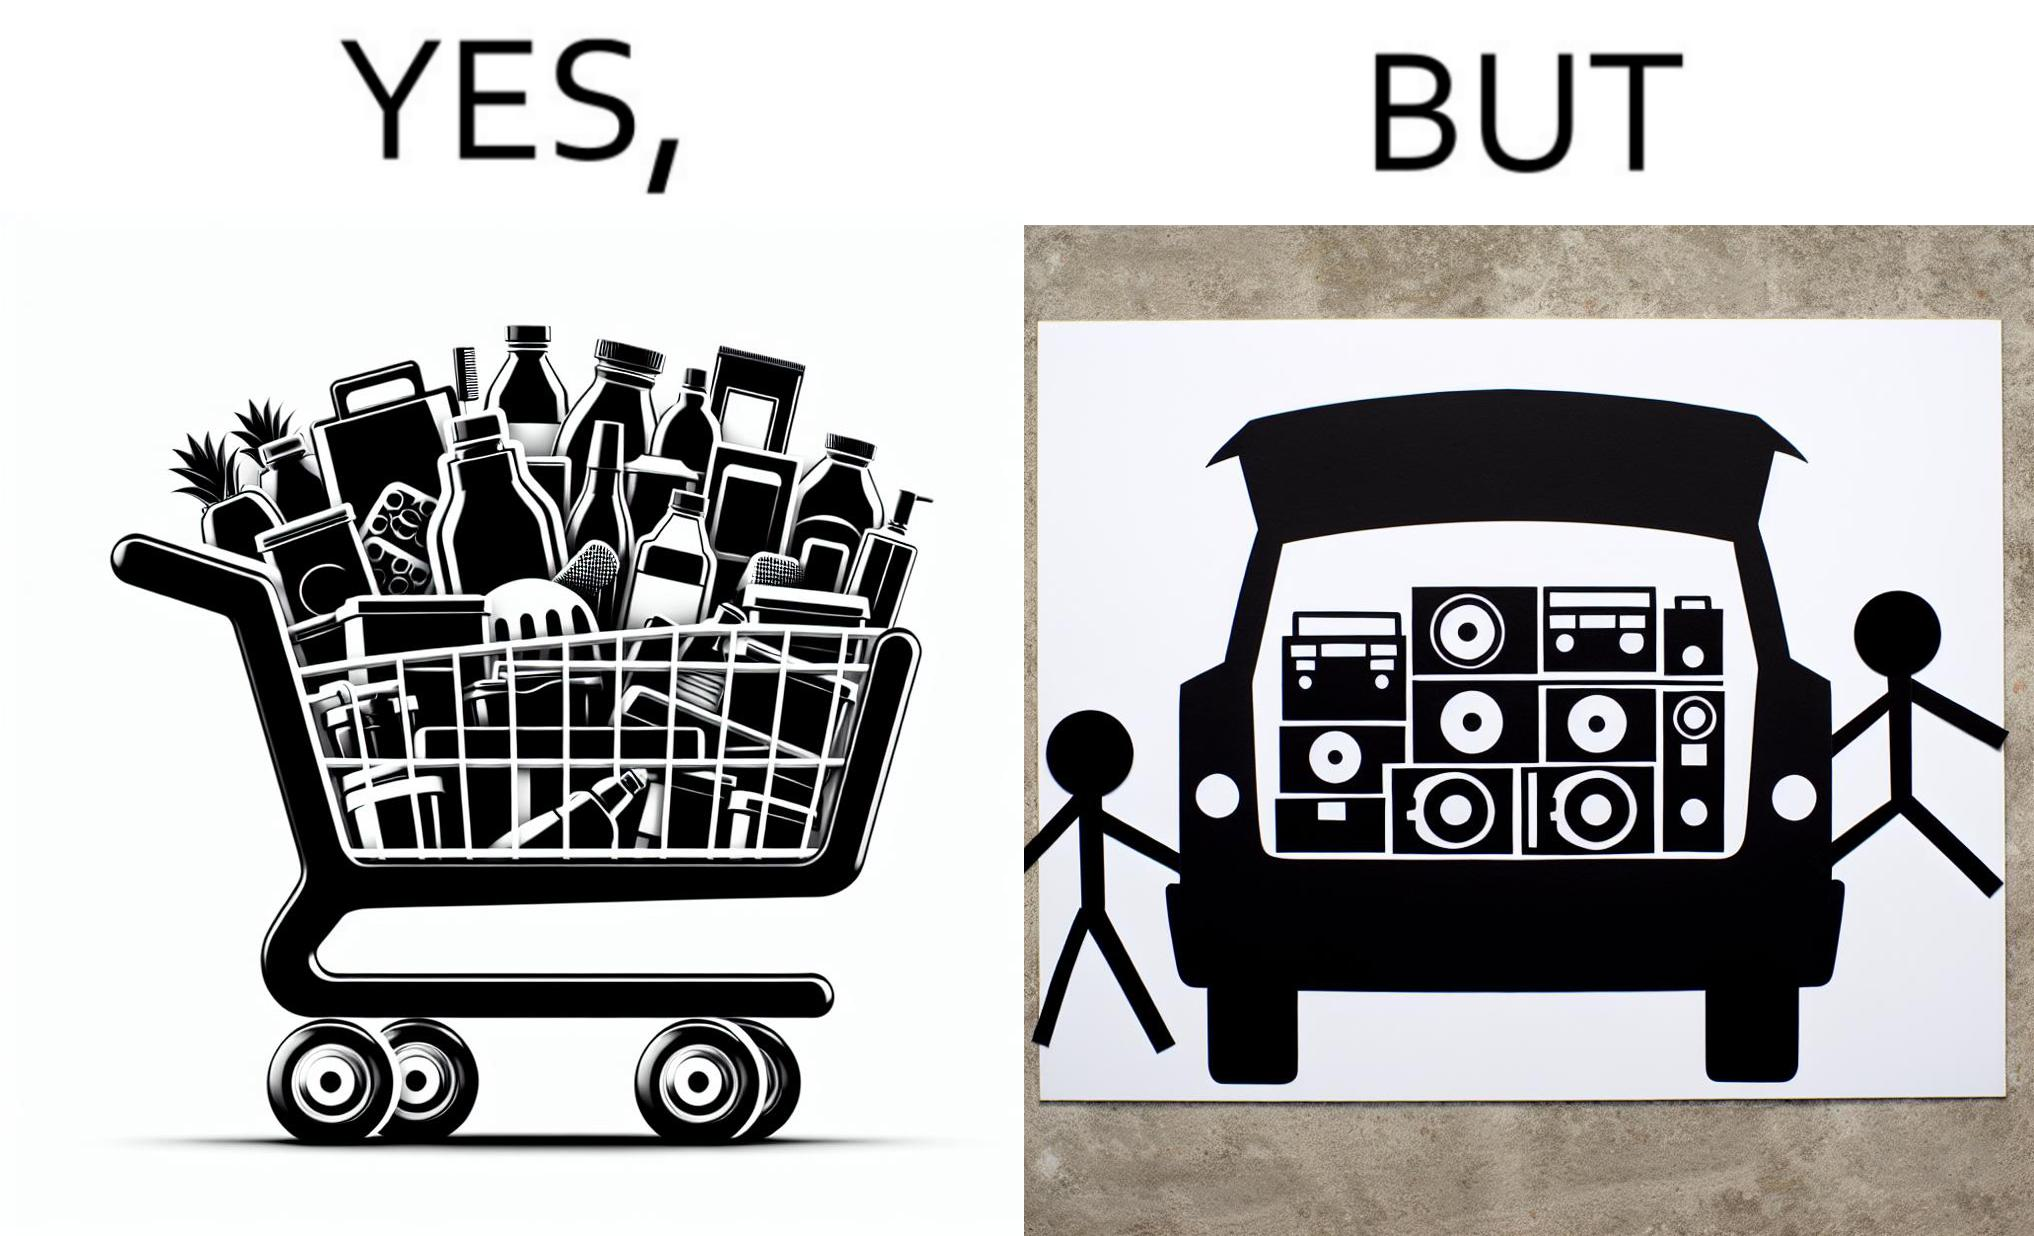Does this image contain satire or humor? Yes, this image is satirical. 